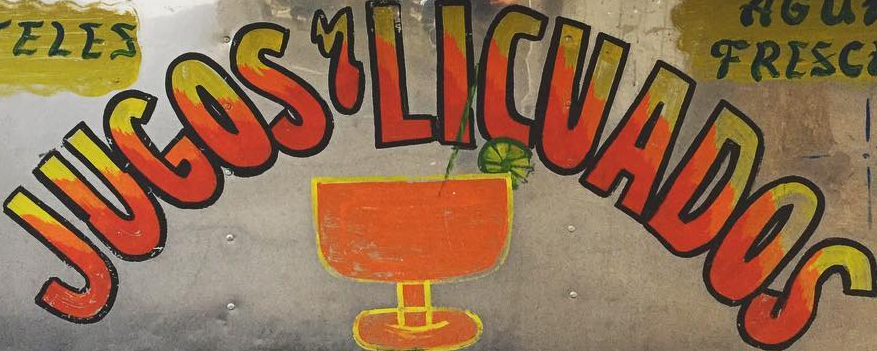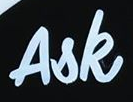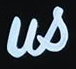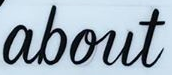Transcribe the words shown in these images in order, separated by a semicolon. JUGOS'LICUADOS; Ask; us; about 